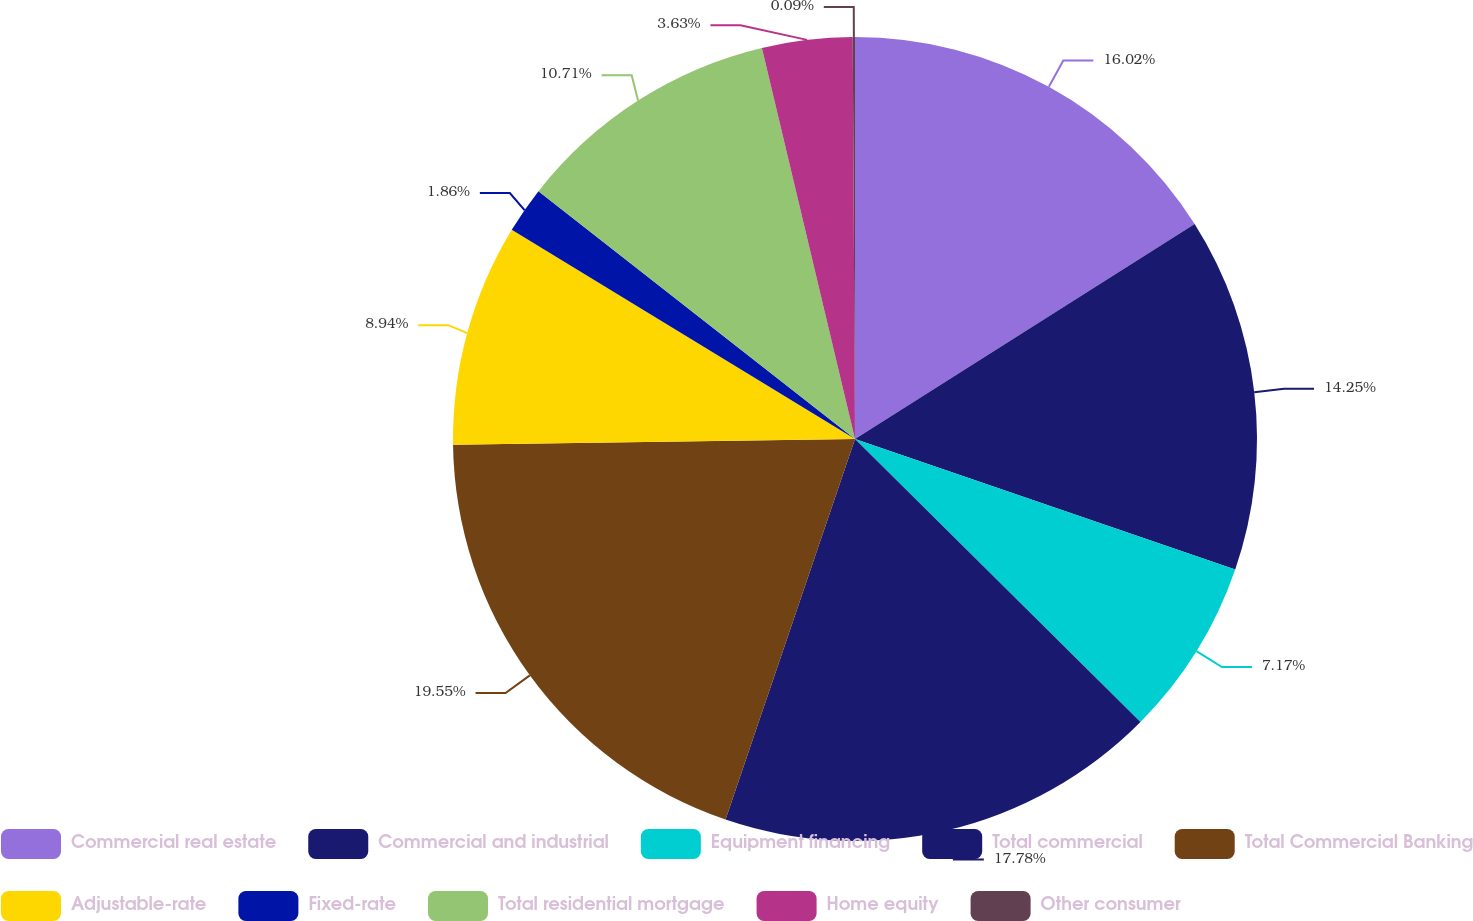Convert chart to OTSL. <chart><loc_0><loc_0><loc_500><loc_500><pie_chart><fcel>Commercial real estate<fcel>Commercial and industrial<fcel>Equipment financing<fcel>Total commercial<fcel>Total Commercial Banking<fcel>Adjustable-rate<fcel>Fixed-rate<fcel>Total residential mortgage<fcel>Home equity<fcel>Other consumer<nl><fcel>16.02%<fcel>14.25%<fcel>7.17%<fcel>17.79%<fcel>19.56%<fcel>8.94%<fcel>1.86%<fcel>10.71%<fcel>3.63%<fcel>0.09%<nl></chart> 